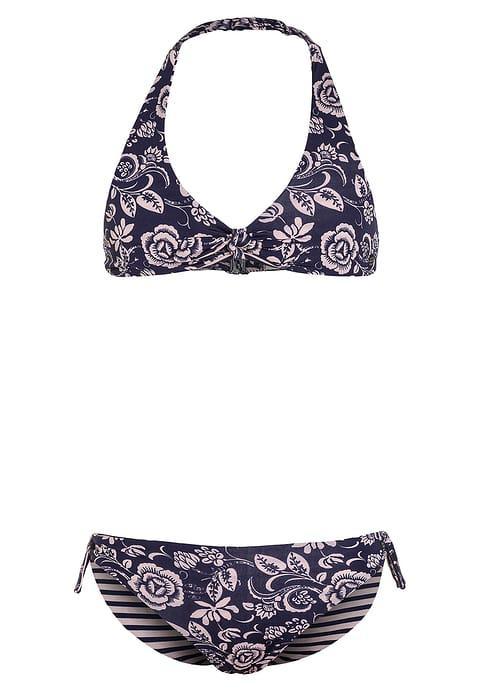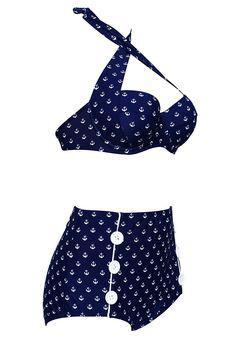The first image is the image on the left, the second image is the image on the right. Assess this claim about the two images: "One of the swimsuits has a floral pattern". Correct or not? Answer yes or no. Yes. 